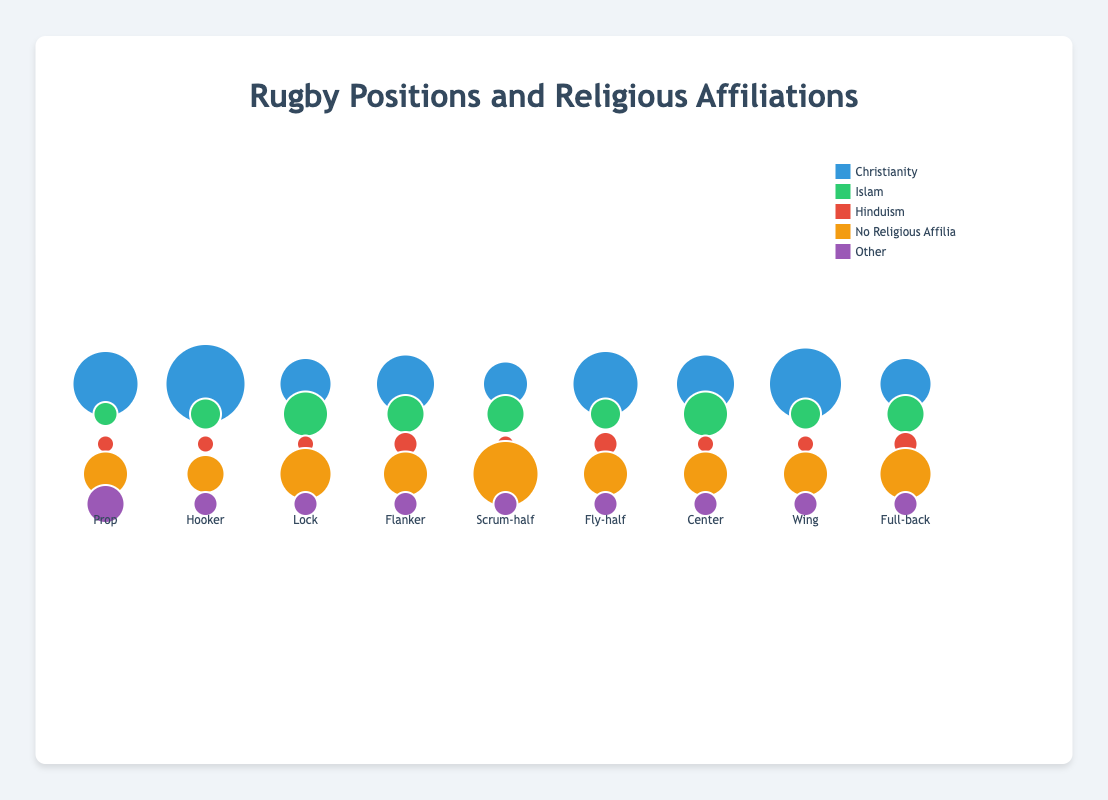What is the proportion of players without any religious affiliation in the position Fly-half? From the chart, locate the position labeled "Fly-half". Observe the bubble labeled "No Religious Affiliation" and note its proportion.
Answer: 25% Which position has the highest proportion of Christian players? Identify the bubbles representing Christianity across all positions in the chart. Compare the proportions and determine the highest.
Answer: Hooker Which positions have the same proportion of Hindu players? Check the bubbles representing Hinduism for all positions and find those with the same size and value.
Answer: Prop, Hooker, Lock, Scrum-half, Wing For the position Center, add up the proportions of players with a religious affiliation. What is the total? For the position Center, sum up the proportions for Christianity, Islam, Hinduism, and Other.
Answer: 75% Which rugby position has the highest diversity of religious affiliations? Examine the spread and size of bubbles for each position. The one with relatively equal and multiple sizeable bubbles indicates higher diversity.
Answer: Prop Compare the proportions of Christian players in the positions Wing and Center. Which position has more Christian players and by how much? Find the Christianity proportion for Wing (45%) and Center (35%). Subtract the two values to find the difference.
Answer: Wing, 10% What is the proportion of Islamic players in the position Full-back? Locate the Full-back position and identify the corresponding bubble for Islam. Note its proportion.
Answer: 20% Which position has the lowest proportion of players with No Religious Affiliation? Check the bubbles for No Religious Affiliation across all positions and find the smallest one.
Answer: Hooker Compare the sum of proportions for players with No Religious Affiliation in Fly-half and Scrum-half positions. Which position has a higher value? Sum up the No Religious Affiliation proportions for Fly-half (25%) and Scrum-half (40%). Compare the totals.
Answer: Scrum-half What is the proportion of players with "Other" religious affiliations in the Prop position? Identify the bubble for "Other" within the Prop position and note its size.
Answer: 20% 